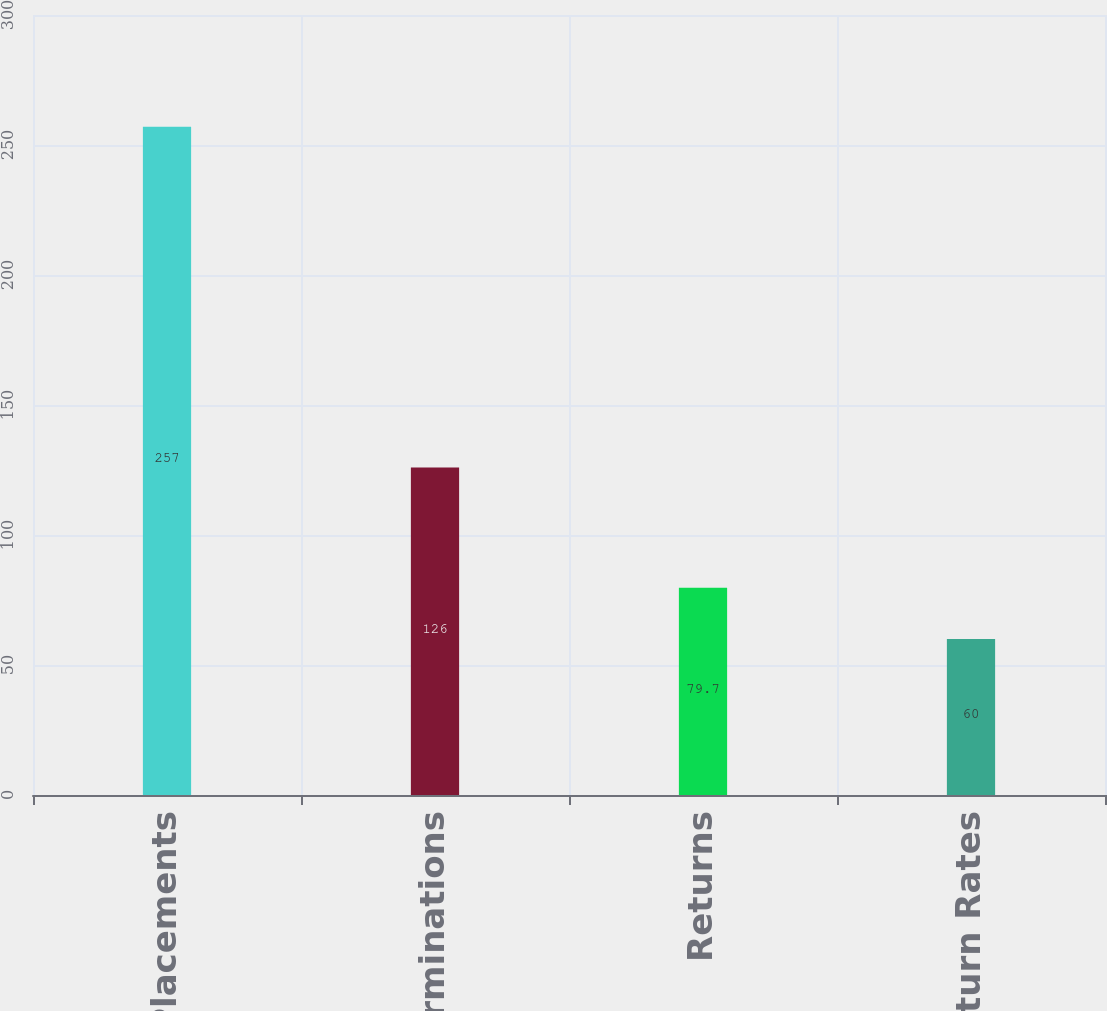<chart> <loc_0><loc_0><loc_500><loc_500><bar_chart><fcel>Placements<fcel>Terminations<fcel>Returns<fcel>Return Rates<nl><fcel>257<fcel>126<fcel>79.7<fcel>60<nl></chart> 